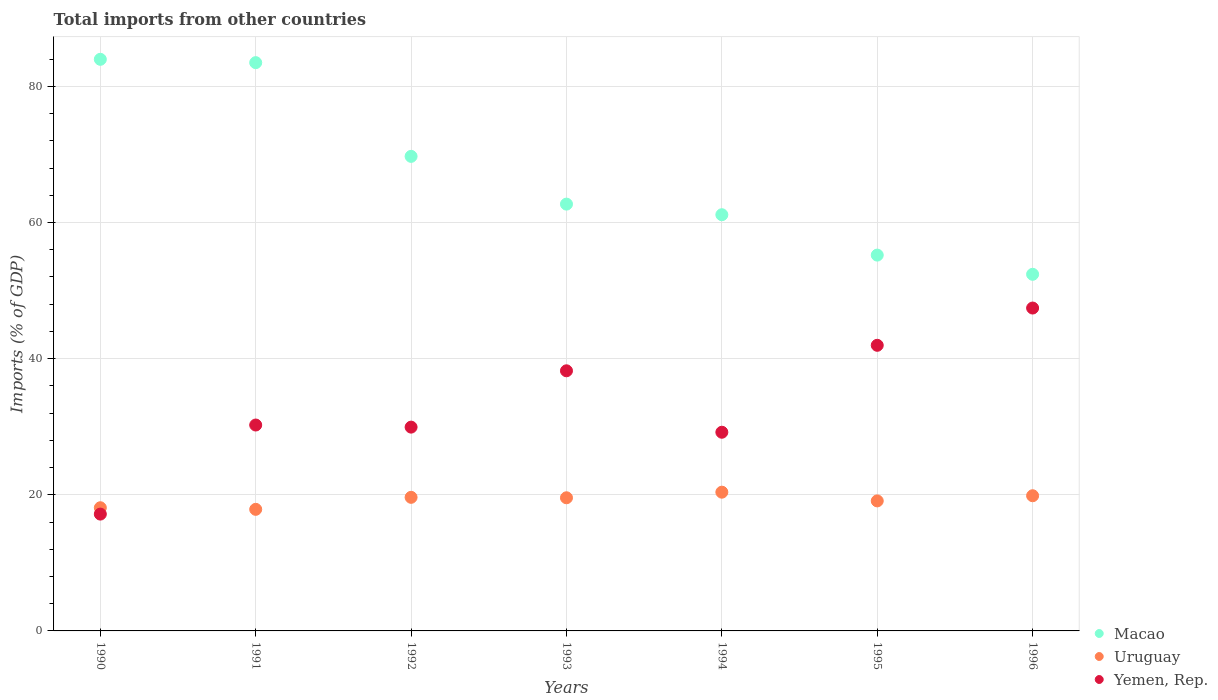How many different coloured dotlines are there?
Your answer should be compact. 3. Is the number of dotlines equal to the number of legend labels?
Provide a succinct answer. Yes. What is the total imports in Macao in 1992?
Provide a succinct answer. 69.71. Across all years, what is the maximum total imports in Macao?
Make the answer very short. 83.97. Across all years, what is the minimum total imports in Yemen, Rep.?
Make the answer very short. 17.16. In which year was the total imports in Uruguay maximum?
Provide a short and direct response. 1994. What is the total total imports in Yemen, Rep. in the graph?
Provide a succinct answer. 234.14. What is the difference between the total imports in Uruguay in 1993 and that in 1995?
Provide a short and direct response. 0.46. What is the difference between the total imports in Yemen, Rep. in 1993 and the total imports in Macao in 1990?
Give a very brief answer. -45.76. What is the average total imports in Yemen, Rep. per year?
Offer a very short reply. 33.45. In the year 1994, what is the difference between the total imports in Uruguay and total imports in Macao?
Provide a succinct answer. -40.76. What is the ratio of the total imports in Macao in 1990 to that in 1991?
Keep it short and to the point. 1.01. Is the total imports in Uruguay in 1990 less than that in 1993?
Offer a very short reply. Yes. What is the difference between the highest and the second highest total imports in Macao?
Ensure brevity in your answer.  0.49. What is the difference between the highest and the lowest total imports in Macao?
Provide a short and direct response. 31.58. In how many years, is the total imports in Macao greater than the average total imports in Macao taken over all years?
Offer a terse response. 3. Is the sum of the total imports in Yemen, Rep. in 1994 and 1995 greater than the maximum total imports in Uruguay across all years?
Make the answer very short. Yes. Does the total imports in Yemen, Rep. monotonically increase over the years?
Give a very brief answer. No. How many years are there in the graph?
Make the answer very short. 7. What is the difference between two consecutive major ticks on the Y-axis?
Your answer should be compact. 20. Are the values on the major ticks of Y-axis written in scientific E-notation?
Your answer should be very brief. No. Where does the legend appear in the graph?
Provide a short and direct response. Bottom right. How are the legend labels stacked?
Your answer should be compact. Vertical. What is the title of the graph?
Offer a terse response. Total imports from other countries. What is the label or title of the Y-axis?
Ensure brevity in your answer.  Imports (% of GDP). What is the Imports (% of GDP) of Macao in 1990?
Make the answer very short. 83.97. What is the Imports (% of GDP) of Uruguay in 1990?
Your answer should be compact. 18.1. What is the Imports (% of GDP) of Yemen, Rep. in 1990?
Provide a short and direct response. 17.16. What is the Imports (% of GDP) of Macao in 1991?
Make the answer very short. 83.48. What is the Imports (% of GDP) of Uruguay in 1991?
Your response must be concise. 17.86. What is the Imports (% of GDP) in Yemen, Rep. in 1991?
Your response must be concise. 30.25. What is the Imports (% of GDP) of Macao in 1992?
Your response must be concise. 69.71. What is the Imports (% of GDP) of Uruguay in 1992?
Offer a very short reply. 19.63. What is the Imports (% of GDP) in Yemen, Rep. in 1992?
Provide a succinct answer. 29.94. What is the Imports (% of GDP) in Macao in 1993?
Make the answer very short. 62.7. What is the Imports (% of GDP) of Uruguay in 1993?
Your answer should be compact. 19.56. What is the Imports (% of GDP) of Yemen, Rep. in 1993?
Make the answer very short. 38.21. What is the Imports (% of GDP) of Macao in 1994?
Your response must be concise. 61.14. What is the Imports (% of GDP) in Uruguay in 1994?
Offer a terse response. 20.38. What is the Imports (% of GDP) of Yemen, Rep. in 1994?
Offer a terse response. 29.19. What is the Imports (% of GDP) in Macao in 1995?
Your answer should be compact. 55.21. What is the Imports (% of GDP) of Uruguay in 1995?
Ensure brevity in your answer.  19.1. What is the Imports (% of GDP) of Yemen, Rep. in 1995?
Your response must be concise. 41.96. What is the Imports (% of GDP) in Macao in 1996?
Ensure brevity in your answer.  52.39. What is the Imports (% of GDP) of Uruguay in 1996?
Offer a terse response. 19.86. What is the Imports (% of GDP) of Yemen, Rep. in 1996?
Your answer should be compact. 47.43. Across all years, what is the maximum Imports (% of GDP) in Macao?
Your answer should be very brief. 83.97. Across all years, what is the maximum Imports (% of GDP) in Uruguay?
Provide a short and direct response. 20.38. Across all years, what is the maximum Imports (% of GDP) of Yemen, Rep.?
Offer a terse response. 47.43. Across all years, what is the minimum Imports (% of GDP) in Macao?
Give a very brief answer. 52.39. Across all years, what is the minimum Imports (% of GDP) in Uruguay?
Provide a succinct answer. 17.86. Across all years, what is the minimum Imports (% of GDP) of Yemen, Rep.?
Ensure brevity in your answer.  17.16. What is the total Imports (% of GDP) of Macao in the graph?
Keep it short and to the point. 468.61. What is the total Imports (% of GDP) of Uruguay in the graph?
Ensure brevity in your answer.  134.48. What is the total Imports (% of GDP) in Yemen, Rep. in the graph?
Provide a succinct answer. 234.14. What is the difference between the Imports (% of GDP) in Macao in 1990 and that in 1991?
Your answer should be very brief. 0.49. What is the difference between the Imports (% of GDP) of Uruguay in 1990 and that in 1991?
Offer a terse response. 0.24. What is the difference between the Imports (% of GDP) of Yemen, Rep. in 1990 and that in 1991?
Make the answer very short. -13.09. What is the difference between the Imports (% of GDP) of Macao in 1990 and that in 1992?
Provide a succinct answer. 14.26. What is the difference between the Imports (% of GDP) in Uruguay in 1990 and that in 1992?
Your answer should be compact. -1.53. What is the difference between the Imports (% of GDP) of Yemen, Rep. in 1990 and that in 1992?
Ensure brevity in your answer.  -12.78. What is the difference between the Imports (% of GDP) of Macao in 1990 and that in 1993?
Your response must be concise. 21.27. What is the difference between the Imports (% of GDP) in Uruguay in 1990 and that in 1993?
Your response must be concise. -1.46. What is the difference between the Imports (% of GDP) of Yemen, Rep. in 1990 and that in 1993?
Offer a very short reply. -21.05. What is the difference between the Imports (% of GDP) in Macao in 1990 and that in 1994?
Make the answer very short. 22.83. What is the difference between the Imports (% of GDP) in Uruguay in 1990 and that in 1994?
Keep it short and to the point. -2.29. What is the difference between the Imports (% of GDP) of Yemen, Rep. in 1990 and that in 1994?
Ensure brevity in your answer.  -12.02. What is the difference between the Imports (% of GDP) of Macao in 1990 and that in 1995?
Offer a very short reply. 28.76. What is the difference between the Imports (% of GDP) of Uruguay in 1990 and that in 1995?
Offer a terse response. -1. What is the difference between the Imports (% of GDP) of Yemen, Rep. in 1990 and that in 1995?
Offer a terse response. -24.8. What is the difference between the Imports (% of GDP) in Macao in 1990 and that in 1996?
Keep it short and to the point. 31.58. What is the difference between the Imports (% of GDP) in Uruguay in 1990 and that in 1996?
Make the answer very short. -1.76. What is the difference between the Imports (% of GDP) in Yemen, Rep. in 1990 and that in 1996?
Your answer should be very brief. -30.27. What is the difference between the Imports (% of GDP) of Macao in 1991 and that in 1992?
Offer a terse response. 13.77. What is the difference between the Imports (% of GDP) in Uruguay in 1991 and that in 1992?
Offer a terse response. -1.76. What is the difference between the Imports (% of GDP) of Yemen, Rep. in 1991 and that in 1992?
Provide a succinct answer. 0.31. What is the difference between the Imports (% of GDP) of Macao in 1991 and that in 1993?
Offer a terse response. 20.78. What is the difference between the Imports (% of GDP) in Uruguay in 1991 and that in 1993?
Give a very brief answer. -1.7. What is the difference between the Imports (% of GDP) of Yemen, Rep. in 1991 and that in 1993?
Make the answer very short. -7.97. What is the difference between the Imports (% of GDP) in Macao in 1991 and that in 1994?
Make the answer very short. 22.34. What is the difference between the Imports (% of GDP) of Uruguay in 1991 and that in 1994?
Provide a succinct answer. -2.52. What is the difference between the Imports (% of GDP) in Yemen, Rep. in 1991 and that in 1994?
Make the answer very short. 1.06. What is the difference between the Imports (% of GDP) of Macao in 1991 and that in 1995?
Offer a terse response. 28.27. What is the difference between the Imports (% of GDP) of Uruguay in 1991 and that in 1995?
Ensure brevity in your answer.  -1.24. What is the difference between the Imports (% of GDP) of Yemen, Rep. in 1991 and that in 1995?
Keep it short and to the point. -11.71. What is the difference between the Imports (% of GDP) in Macao in 1991 and that in 1996?
Offer a very short reply. 31.09. What is the difference between the Imports (% of GDP) in Uruguay in 1991 and that in 1996?
Give a very brief answer. -2. What is the difference between the Imports (% of GDP) of Yemen, Rep. in 1991 and that in 1996?
Make the answer very short. -17.19. What is the difference between the Imports (% of GDP) in Macao in 1992 and that in 1993?
Offer a very short reply. 7.02. What is the difference between the Imports (% of GDP) in Uruguay in 1992 and that in 1993?
Make the answer very short. 0.07. What is the difference between the Imports (% of GDP) of Yemen, Rep. in 1992 and that in 1993?
Provide a succinct answer. -8.28. What is the difference between the Imports (% of GDP) of Macao in 1992 and that in 1994?
Provide a short and direct response. 8.57. What is the difference between the Imports (% of GDP) of Uruguay in 1992 and that in 1994?
Keep it short and to the point. -0.76. What is the difference between the Imports (% of GDP) of Yemen, Rep. in 1992 and that in 1994?
Your response must be concise. 0.75. What is the difference between the Imports (% of GDP) of Macao in 1992 and that in 1995?
Offer a terse response. 14.5. What is the difference between the Imports (% of GDP) in Uruguay in 1992 and that in 1995?
Your answer should be very brief. 0.52. What is the difference between the Imports (% of GDP) of Yemen, Rep. in 1992 and that in 1995?
Keep it short and to the point. -12.02. What is the difference between the Imports (% of GDP) in Macao in 1992 and that in 1996?
Provide a short and direct response. 17.33. What is the difference between the Imports (% of GDP) in Uruguay in 1992 and that in 1996?
Your answer should be very brief. -0.23. What is the difference between the Imports (% of GDP) of Yemen, Rep. in 1992 and that in 1996?
Provide a succinct answer. -17.49. What is the difference between the Imports (% of GDP) of Macao in 1993 and that in 1994?
Offer a terse response. 1.56. What is the difference between the Imports (% of GDP) of Uruguay in 1993 and that in 1994?
Offer a terse response. -0.82. What is the difference between the Imports (% of GDP) in Yemen, Rep. in 1993 and that in 1994?
Keep it short and to the point. 9.03. What is the difference between the Imports (% of GDP) in Macao in 1993 and that in 1995?
Offer a terse response. 7.49. What is the difference between the Imports (% of GDP) of Uruguay in 1993 and that in 1995?
Provide a short and direct response. 0.46. What is the difference between the Imports (% of GDP) in Yemen, Rep. in 1993 and that in 1995?
Your answer should be compact. -3.74. What is the difference between the Imports (% of GDP) in Macao in 1993 and that in 1996?
Your response must be concise. 10.31. What is the difference between the Imports (% of GDP) in Uruguay in 1993 and that in 1996?
Your answer should be compact. -0.3. What is the difference between the Imports (% of GDP) of Yemen, Rep. in 1993 and that in 1996?
Give a very brief answer. -9.22. What is the difference between the Imports (% of GDP) in Macao in 1994 and that in 1995?
Give a very brief answer. 5.93. What is the difference between the Imports (% of GDP) in Uruguay in 1994 and that in 1995?
Your response must be concise. 1.28. What is the difference between the Imports (% of GDP) of Yemen, Rep. in 1994 and that in 1995?
Offer a terse response. -12.77. What is the difference between the Imports (% of GDP) in Macao in 1994 and that in 1996?
Your answer should be very brief. 8.75. What is the difference between the Imports (% of GDP) in Uruguay in 1994 and that in 1996?
Offer a terse response. 0.52. What is the difference between the Imports (% of GDP) in Yemen, Rep. in 1994 and that in 1996?
Keep it short and to the point. -18.25. What is the difference between the Imports (% of GDP) of Macao in 1995 and that in 1996?
Provide a short and direct response. 2.82. What is the difference between the Imports (% of GDP) in Uruguay in 1995 and that in 1996?
Offer a very short reply. -0.76. What is the difference between the Imports (% of GDP) of Yemen, Rep. in 1995 and that in 1996?
Ensure brevity in your answer.  -5.47. What is the difference between the Imports (% of GDP) in Macao in 1990 and the Imports (% of GDP) in Uruguay in 1991?
Give a very brief answer. 66.11. What is the difference between the Imports (% of GDP) of Macao in 1990 and the Imports (% of GDP) of Yemen, Rep. in 1991?
Make the answer very short. 53.72. What is the difference between the Imports (% of GDP) of Uruguay in 1990 and the Imports (% of GDP) of Yemen, Rep. in 1991?
Provide a short and direct response. -12.15. What is the difference between the Imports (% of GDP) in Macao in 1990 and the Imports (% of GDP) in Uruguay in 1992?
Provide a succinct answer. 64.35. What is the difference between the Imports (% of GDP) in Macao in 1990 and the Imports (% of GDP) in Yemen, Rep. in 1992?
Ensure brevity in your answer.  54.03. What is the difference between the Imports (% of GDP) in Uruguay in 1990 and the Imports (% of GDP) in Yemen, Rep. in 1992?
Your answer should be very brief. -11.84. What is the difference between the Imports (% of GDP) in Macao in 1990 and the Imports (% of GDP) in Uruguay in 1993?
Provide a short and direct response. 64.41. What is the difference between the Imports (% of GDP) of Macao in 1990 and the Imports (% of GDP) of Yemen, Rep. in 1993?
Your answer should be very brief. 45.76. What is the difference between the Imports (% of GDP) of Uruguay in 1990 and the Imports (% of GDP) of Yemen, Rep. in 1993?
Your answer should be compact. -20.12. What is the difference between the Imports (% of GDP) in Macao in 1990 and the Imports (% of GDP) in Uruguay in 1994?
Your answer should be very brief. 63.59. What is the difference between the Imports (% of GDP) in Macao in 1990 and the Imports (% of GDP) in Yemen, Rep. in 1994?
Offer a very short reply. 54.78. What is the difference between the Imports (% of GDP) of Uruguay in 1990 and the Imports (% of GDP) of Yemen, Rep. in 1994?
Your response must be concise. -11.09. What is the difference between the Imports (% of GDP) in Macao in 1990 and the Imports (% of GDP) in Uruguay in 1995?
Provide a short and direct response. 64.87. What is the difference between the Imports (% of GDP) of Macao in 1990 and the Imports (% of GDP) of Yemen, Rep. in 1995?
Your response must be concise. 42.01. What is the difference between the Imports (% of GDP) of Uruguay in 1990 and the Imports (% of GDP) of Yemen, Rep. in 1995?
Your response must be concise. -23.86. What is the difference between the Imports (% of GDP) in Macao in 1990 and the Imports (% of GDP) in Uruguay in 1996?
Provide a succinct answer. 64.11. What is the difference between the Imports (% of GDP) in Macao in 1990 and the Imports (% of GDP) in Yemen, Rep. in 1996?
Give a very brief answer. 36.54. What is the difference between the Imports (% of GDP) of Uruguay in 1990 and the Imports (% of GDP) of Yemen, Rep. in 1996?
Keep it short and to the point. -29.34. What is the difference between the Imports (% of GDP) in Macao in 1991 and the Imports (% of GDP) in Uruguay in 1992?
Give a very brief answer. 63.86. What is the difference between the Imports (% of GDP) of Macao in 1991 and the Imports (% of GDP) of Yemen, Rep. in 1992?
Give a very brief answer. 53.54. What is the difference between the Imports (% of GDP) of Uruguay in 1991 and the Imports (% of GDP) of Yemen, Rep. in 1992?
Offer a very short reply. -12.08. What is the difference between the Imports (% of GDP) in Macao in 1991 and the Imports (% of GDP) in Uruguay in 1993?
Your answer should be compact. 63.92. What is the difference between the Imports (% of GDP) in Macao in 1991 and the Imports (% of GDP) in Yemen, Rep. in 1993?
Provide a short and direct response. 45.27. What is the difference between the Imports (% of GDP) in Uruguay in 1991 and the Imports (% of GDP) in Yemen, Rep. in 1993?
Give a very brief answer. -20.35. What is the difference between the Imports (% of GDP) of Macao in 1991 and the Imports (% of GDP) of Uruguay in 1994?
Offer a very short reply. 63.1. What is the difference between the Imports (% of GDP) of Macao in 1991 and the Imports (% of GDP) of Yemen, Rep. in 1994?
Your answer should be very brief. 54.3. What is the difference between the Imports (% of GDP) in Uruguay in 1991 and the Imports (% of GDP) in Yemen, Rep. in 1994?
Provide a succinct answer. -11.33. What is the difference between the Imports (% of GDP) of Macao in 1991 and the Imports (% of GDP) of Uruguay in 1995?
Your answer should be compact. 64.38. What is the difference between the Imports (% of GDP) of Macao in 1991 and the Imports (% of GDP) of Yemen, Rep. in 1995?
Your response must be concise. 41.52. What is the difference between the Imports (% of GDP) in Uruguay in 1991 and the Imports (% of GDP) in Yemen, Rep. in 1995?
Your response must be concise. -24.1. What is the difference between the Imports (% of GDP) of Macao in 1991 and the Imports (% of GDP) of Uruguay in 1996?
Make the answer very short. 63.62. What is the difference between the Imports (% of GDP) in Macao in 1991 and the Imports (% of GDP) in Yemen, Rep. in 1996?
Keep it short and to the point. 36.05. What is the difference between the Imports (% of GDP) of Uruguay in 1991 and the Imports (% of GDP) of Yemen, Rep. in 1996?
Ensure brevity in your answer.  -29.57. What is the difference between the Imports (% of GDP) in Macao in 1992 and the Imports (% of GDP) in Uruguay in 1993?
Your answer should be very brief. 50.16. What is the difference between the Imports (% of GDP) in Macao in 1992 and the Imports (% of GDP) in Yemen, Rep. in 1993?
Offer a very short reply. 31.5. What is the difference between the Imports (% of GDP) in Uruguay in 1992 and the Imports (% of GDP) in Yemen, Rep. in 1993?
Make the answer very short. -18.59. What is the difference between the Imports (% of GDP) of Macao in 1992 and the Imports (% of GDP) of Uruguay in 1994?
Offer a terse response. 49.33. What is the difference between the Imports (% of GDP) in Macao in 1992 and the Imports (% of GDP) in Yemen, Rep. in 1994?
Give a very brief answer. 40.53. What is the difference between the Imports (% of GDP) of Uruguay in 1992 and the Imports (% of GDP) of Yemen, Rep. in 1994?
Offer a terse response. -9.56. What is the difference between the Imports (% of GDP) in Macao in 1992 and the Imports (% of GDP) in Uruguay in 1995?
Make the answer very short. 50.61. What is the difference between the Imports (% of GDP) in Macao in 1992 and the Imports (% of GDP) in Yemen, Rep. in 1995?
Your answer should be compact. 27.76. What is the difference between the Imports (% of GDP) of Uruguay in 1992 and the Imports (% of GDP) of Yemen, Rep. in 1995?
Your response must be concise. -22.33. What is the difference between the Imports (% of GDP) of Macao in 1992 and the Imports (% of GDP) of Uruguay in 1996?
Offer a terse response. 49.86. What is the difference between the Imports (% of GDP) of Macao in 1992 and the Imports (% of GDP) of Yemen, Rep. in 1996?
Give a very brief answer. 22.28. What is the difference between the Imports (% of GDP) of Uruguay in 1992 and the Imports (% of GDP) of Yemen, Rep. in 1996?
Your answer should be compact. -27.81. What is the difference between the Imports (% of GDP) in Macao in 1993 and the Imports (% of GDP) in Uruguay in 1994?
Provide a succinct answer. 42.32. What is the difference between the Imports (% of GDP) in Macao in 1993 and the Imports (% of GDP) in Yemen, Rep. in 1994?
Your answer should be very brief. 33.51. What is the difference between the Imports (% of GDP) in Uruguay in 1993 and the Imports (% of GDP) in Yemen, Rep. in 1994?
Offer a very short reply. -9.63. What is the difference between the Imports (% of GDP) of Macao in 1993 and the Imports (% of GDP) of Uruguay in 1995?
Keep it short and to the point. 43.6. What is the difference between the Imports (% of GDP) of Macao in 1993 and the Imports (% of GDP) of Yemen, Rep. in 1995?
Provide a short and direct response. 20.74. What is the difference between the Imports (% of GDP) in Uruguay in 1993 and the Imports (% of GDP) in Yemen, Rep. in 1995?
Ensure brevity in your answer.  -22.4. What is the difference between the Imports (% of GDP) of Macao in 1993 and the Imports (% of GDP) of Uruguay in 1996?
Provide a short and direct response. 42.84. What is the difference between the Imports (% of GDP) of Macao in 1993 and the Imports (% of GDP) of Yemen, Rep. in 1996?
Provide a short and direct response. 15.27. What is the difference between the Imports (% of GDP) of Uruguay in 1993 and the Imports (% of GDP) of Yemen, Rep. in 1996?
Ensure brevity in your answer.  -27.87. What is the difference between the Imports (% of GDP) of Macao in 1994 and the Imports (% of GDP) of Uruguay in 1995?
Give a very brief answer. 42.04. What is the difference between the Imports (% of GDP) in Macao in 1994 and the Imports (% of GDP) in Yemen, Rep. in 1995?
Provide a short and direct response. 19.18. What is the difference between the Imports (% of GDP) in Uruguay in 1994 and the Imports (% of GDP) in Yemen, Rep. in 1995?
Give a very brief answer. -21.58. What is the difference between the Imports (% of GDP) in Macao in 1994 and the Imports (% of GDP) in Uruguay in 1996?
Keep it short and to the point. 41.28. What is the difference between the Imports (% of GDP) of Macao in 1994 and the Imports (% of GDP) of Yemen, Rep. in 1996?
Provide a succinct answer. 13.71. What is the difference between the Imports (% of GDP) of Uruguay in 1994 and the Imports (% of GDP) of Yemen, Rep. in 1996?
Offer a terse response. -27.05. What is the difference between the Imports (% of GDP) in Macao in 1995 and the Imports (% of GDP) in Uruguay in 1996?
Keep it short and to the point. 35.35. What is the difference between the Imports (% of GDP) of Macao in 1995 and the Imports (% of GDP) of Yemen, Rep. in 1996?
Keep it short and to the point. 7.78. What is the difference between the Imports (% of GDP) in Uruguay in 1995 and the Imports (% of GDP) in Yemen, Rep. in 1996?
Offer a very short reply. -28.33. What is the average Imports (% of GDP) in Macao per year?
Make the answer very short. 66.94. What is the average Imports (% of GDP) in Uruguay per year?
Your response must be concise. 19.21. What is the average Imports (% of GDP) of Yemen, Rep. per year?
Offer a very short reply. 33.45. In the year 1990, what is the difference between the Imports (% of GDP) in Macao and Imports (% of GDP) in Uruguay?
Your answer should be compact. 65.88. In the year 1990, what is the difference between the Imports (% of GDP) of Macao and Imports (% of GDP) of Yemen, Rep.?
Offer a very short reply. 66.81. In the year 1990, what is the difference between the Imports (% of GDP) of Uruguay and Imports (% of GDP) of Yemen, Rep.?
Offer a very short reply. 0.93. In the year 1991, what is the difference between the Imports (% of GDP) in Macao and Imports (% of GDP) in Uruguay?
Your response must be concise. 65.62. In the year 1991, what is the difference between the Imports (% of GDP) in Macao and Imports (% of GDP) in Yemen, Rep.?
Give a very brief answer. 53.23. In the year 1991, what is the difference between the Imports (% of GDP) of Uruguay and Imports (% of GDP) of Yemen, Rep.?
Your answer should be very brief. -12.39. In the year 1992, what is the difference between the Imports (% of GDP) of Macao and Imports (% of GDP) of Uruguay?
Ensure brevity in your answer.  50.09. In the year 1992, what is the difference between the Imports (% of GDP) in Macao and Imports (% of GDP) in Yemen, Rep.?
Offer a terse response. 39.78. In the year 1992, what is the difference between the Imports (% of GDP) in Uruguay and Imports (% of GDP) in Yemen, Rep.?
Offer a terse response. -10.31. In the year 1993, what is the difference between the Imports (% of GDP) in Macao and Imports (% of GDP) in Uruguay?
Your answer should be compact. 43.14. In the year 1993, what is the difference between the Imports (% of GDP) of Macao and Imports (% of GDP) of Yemen, Rep.?
Give a very brief answer. 24.49. In the year 1993, what is the difference between the Imports (% of GDP) of Uruguay and Imports (% of GDP) of Yemen, Rep.?
Give a very brief answer. -18.65. In the year 1994, what is the difference between the Imports (% of GDP) in Macao and Imports (% of GDP) in Uruguay?
Make the answer very short. 40.76. In the year 1994, what is the difference between the Imports (% of GDP) in Macao and Imports (% of GDP) in Yemen, Rep.?
Make the answer very short. 31.95. In the year 1994, what is the difference between the Imports (% of GDP) of Uruguay and Imports (% of GDP) of Yemen, Rep.?
Your answer should be compact. -8.8. In the year 1995, what is the difference between the Imports (% of GDP) in Macao and Imports (% of GDP) in Uruguay?
Your answer should be compact. 36.11. In the year 1995, what is the difference between the Imports (% of GDP) in Macao and Imports (% of GDP) in Yemen, Rep.?
Ensure brevity in your answer.  13.25. In the year 1995, what is the difference between the Imports (% of GDP) in Uruguay and Imports (% of GDP) in Yemen, Rep.?
Give a very brief answer. -22.86. In the year 1996, what is the difference between the Imports (% of GDP) of Macao and Imports (% of GDP) of Uruguay?
Your answer should be very brief. 32.53. In the year 1996, what is the difference between the Imports (% of GDP) in Macao and Imports (% of GDP) in Yemen, Rep.?
Your answer should be compact. 4.96. In the year 1996, what is the difference between the Imports (% of GDP) of Uruguay and Imports (% of GDP) of Yemen, Rep.?
Offer a very short reply. -27.57. What is the ratio of the Imports (% of GDP) in Macao in 1990 to that in 1991?
Make the answer very short. 1.01. What is the ratio of the Imports (% of GDP) in Uruguay in 1990 to that in 1991?
Ensure brevity in your answer.  1.01. What is the ratio of the Imports (% of GDP) in Yemen, Rep. in 1990 to that in 1991?
Give a very brief answer. 0.57. What is the ratio of the Imports (% of GDP) in Macao in 1990 to that in 1992?
Offer a terse response. 1.2. What is the ratio of the Imports (% of GDP) of Uruguay in 1990 to that in 1992?
Offer a terse response. 0.92. What is the ratio of the Imports (% of GDP) of Yemen, Rep. in 1990 to that in 1992?
Ensure brevity in your answer.  0.57. What is the ratio of the Imports (% of GDP) in Macao in 1990 to that in 1993?
Offer a very short reply. 1.34. What is the ratio of the Imports (% of GDP) of Uruguay in 1990 to that in 1993?
Offer a very short reply. 0.93. What is the ratio of the Imports (% of GDP) in Yemen, Rep. in 1990 to that in 1993?
Offer a very short reply. 0.45. What is the ratio of the Imports (% of GDP) in Macao in 1990 to that in 1994?
Give a very brief answer. 1.37. What is the ratio of the Imports (% of GDP) in Uruguay in 1990 to that in 1994?
Ensure brevity in your answer.  0.89. What is the ratio of the Imports (% of GDP) in Yemen, Rep. in 1990 to that in 1994?
Offer a terse response. 0.59. What is the ratio of the Imports (% of GDP) in Macao in 1990 to that in 1995?
Offer a very short reply. 1.52. What is the ratio of the Imports (% of GDP) in Yemen, Rep. in 1990 to that in 1995?
Ensure brevity in your answer.  0.41. What is the ratio of the Imports (% of GDP) in Macao in 1990 to that in 1996?
Offer a terse response. 1.6. What is the ratio of the Imports (% of GDP) of Uruguay in 1990 to that in 1996?
Ensure brevity in your answer.  0.91. What is the ratio of the Imports (% of GDP) in Yemen, Rep. in 1990 to that in 1996?
Your answer should be compact. 0.36. What is the ratio of the Imports (% of GDP) of Macao in 1991 to that in 1992?
Provide a succinct answer. 1.2. What is the ratio of the Imports (% of GDP) in Uruguay in 1991 to that in 1992?
Offer a terse response. 0.91. What is the ratio of the Imports (% of GDP) in Yemen, Rep. in 1991 to that in 1992?
Make the answer very short. 1.01. What is the ratio of the Imports (% of GDP) of Macao in 1991 to that in 1993?
Provide a succinct answer. 1.33. What is the ratio of the Imports (% of GDP) in Uruguay in 1991 to that in 1993?
Your answer should be compact. 0.91. What is the ratio of the Imports (% of GDP) of Yemen, Rep. in 1991 to that in 1993?
Keep it short and to the point. 0.79. What is the ratio of the Imports (% of GDP) in Macao in 1991 to that in 1994?
Your response must be concise. 1.37. What is the ratio of the Imports (% of GDP) of Uruguay in 1991 to that in 1994?
Offer a very short reply. 0.88. What is the ratio of the Imports (% of GDP) in Yemen, Rep. in 1991 to that in 1994?
Ensure brevity in your answer.  1.04. What is the ratio of the Imports (% of GDP) of Macao in 1991 to that in 1995?
Your response must be concise. 1.51. What is the ratio of the Imports (% of GDP) of Uruguay in 1991 to that in 1995?
Keep it short and to the point. 0.94. What is the ratio of the Imports (% of GDP) of Yemen, Rep. in 1991 to that in 1995?
Your answer should be compact. 0.72. What is the ratio of the Imports (% of GDP) in Macao in 1991 to that in 1996?
Offer a terse response. 1.59. What is the ratio of the Imports (% of GDP) of Uruguay in 1991 to that in 1996?
Your response must be concise. 0.9. What is the ratio of the Imports (% of GDP) in Yemen, Rep. in 1991 to that in 1996?
Keep it short and to the point. 0.64. What is the ratio of the Imports (% of GDP) of Macao in 1992 to that in 1993?
Ensure brevity in your answer.  1.11. What is the ratio of the Imports (% of GDP) in Uruguay in 1992 to that in 1993?
Your response must be concise. 1. What is the ratio of the Imports (% of GDP) in Yemen, Rep. in 1992 to that in 1993?
Your answer should be compact. 0.78. What is the ratio of the Imports (% of GDP) in Macao in 1992 to that in 1994?
Give a very brief answer. 1.14. What is the ratio of the Imports (% of GDP) of Uruguay in 1992 to that in 1994?
Offer a terse response. 0.96. What is the ratio of the Imports (% of GDP) of Yemen, Rep. in 1992 to that in 1994?
Your answer should be very brief. 1.03. What is the ratio of the Imports (% of GDP) of Macao in 1992 to that in 1995?
Offer a terse response. 1.26. What is the ratio of the Imports (% of GDP) in Uruguay in 1992 to that in 1995?
Offer a terse response. 1.03. What is the ratio of the Imports (% of GDP) of Yemen, Rep. in 1992 to that in 1995?
Offer a very short reply. 0.71. What is the ratio of the Imports (% of GDP) in Macao in 1992 to that in 1996?
Your response must be concise. 1.33. What is the ratio of the Imports (% of GDP) of Uruguay in 1992 to that in 1996?
Provide a succinct answer. 0.99. What is the ratio of the Imports (% of GDP) in Yemen, Rep. in 1992 to that in 1996?
Keep it short and to the point. 0.63. What is the ratio of the Imports (% of GDP) in Macao in 1993 to that in 1994?
Ensure brevity in your answer.  1.03. What is the ratio of the Imports (% of GDP) of Uruguay in 1993 to that in 1994?
Offer a terse response. 0.96. What is the ratio of the Imports (% of GDP) of Yemen, Rep. in 1993 to that in 1994?
Offer a very short reply. 1.31. What is the ratio of the Imports (% of GDP) in Macao in 1993 to that in 1995?
Ensure brevity in your answer.  1.14. What is the ratio of the Imports (% of GDP) in Yemen, Rep. in 1993 to that in 1995?
Provide a short and direct response. 0.91. What is the ratio of the Imports (% of GDP) in Macao in 1993 to that in 1996?
Your answer should be compact. 1.2. What is the ratio of the Imports (% of GDP) in Uruguay in 1993 to that in 1996?
Provide a succinct answer. 0.98. What is the ratio of the Imports (% of GDP) of Yemen, Rep. in 1993 to that in 1996?
Offer a very short reply. 0.81. What is the ratio of the Imports (% of GDP) of Macao in 1994 to that in 1995?
Offer a very short reply. 1.11. What is the ratio of the Imports (% of GDP) in Uruguay in 1994 to that in 1995?
Your answer should be very brief. 1.07. What is the ratio of the Imports (% of GDP) of Yemen, Rep. in 1994 to that in 1995?
Provide a succinct answer. 0.7. What is the ratio of the Imports (% of GDP) in Macao in 1994 to that in 1996?
Keep it short and to the point. 1.17. What is the ratio of the Imports (% of GDP) of Uruguay in 1994 to that in 1996?
Provide a succinct answer. 1.03. What is the ratio of the Imports (% of GDP) of Yemen, Rep. in 1994 to that in 1996?
Give a very brief answer. 0.62. What is the ratio of the Imports (% of GDP) of Macao in 1995 to that in 1996?
Give a very brief answer. 1.05. What is the ratio of the Imports (% of GDP) in Uruguay in 1995 to that in 1996?
Offer a very short reply. 0.96. What is the ratio of the Imports (% of GDP) in Yemen, Rep. in 1995 to that in 1996?
Your response must be concise. 0.88. What is the difference between the highest and the second highest Imports (% of GDP) of Macao?
Ensure brevity in your answer.  0.49. What is the difference between the highest and the second highest Imports (% of GDP) of Uruguay?
Offer a very short reply. 0.52. What is the difference between the highest and the second highest Imports (% of GDP) in Yemen, Rep.?
Offer a terse response. 5.47. What is the difference between the highest and the lowest Imports (% of GDP) of Macao?
Give a very brief answer. 31.58. What is the difference between the highest and the lowest Imports (% of GDP) of Uruguay?
Your answer should be very brief. 2.52. What is the difference between the highest and the lowest Imports (% of GDP) of Yemen, Rep.?
Make the answer very short. 30.27. 